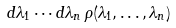Convert formula to latex. <formula><loc_0><loc_0><loc_500><loc_500>d \lambda _ { 1 } \cdots d \lambda _ { n } \, \rho ( \lambda _ { 1 } , \dots , \lambda _ { n } )</formula> 